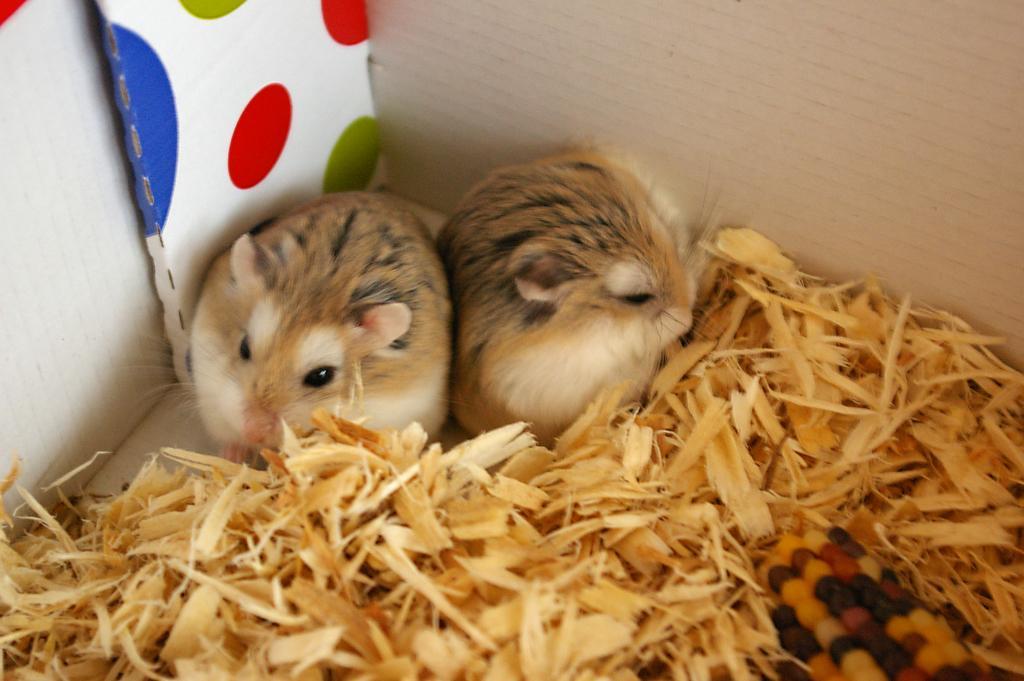Can you describe this image briefly? In this image I can see two hamsters which are brown, cream and black in color. I can see the wood dust and a colorful corn in front of them. In the background I can see the walls. 